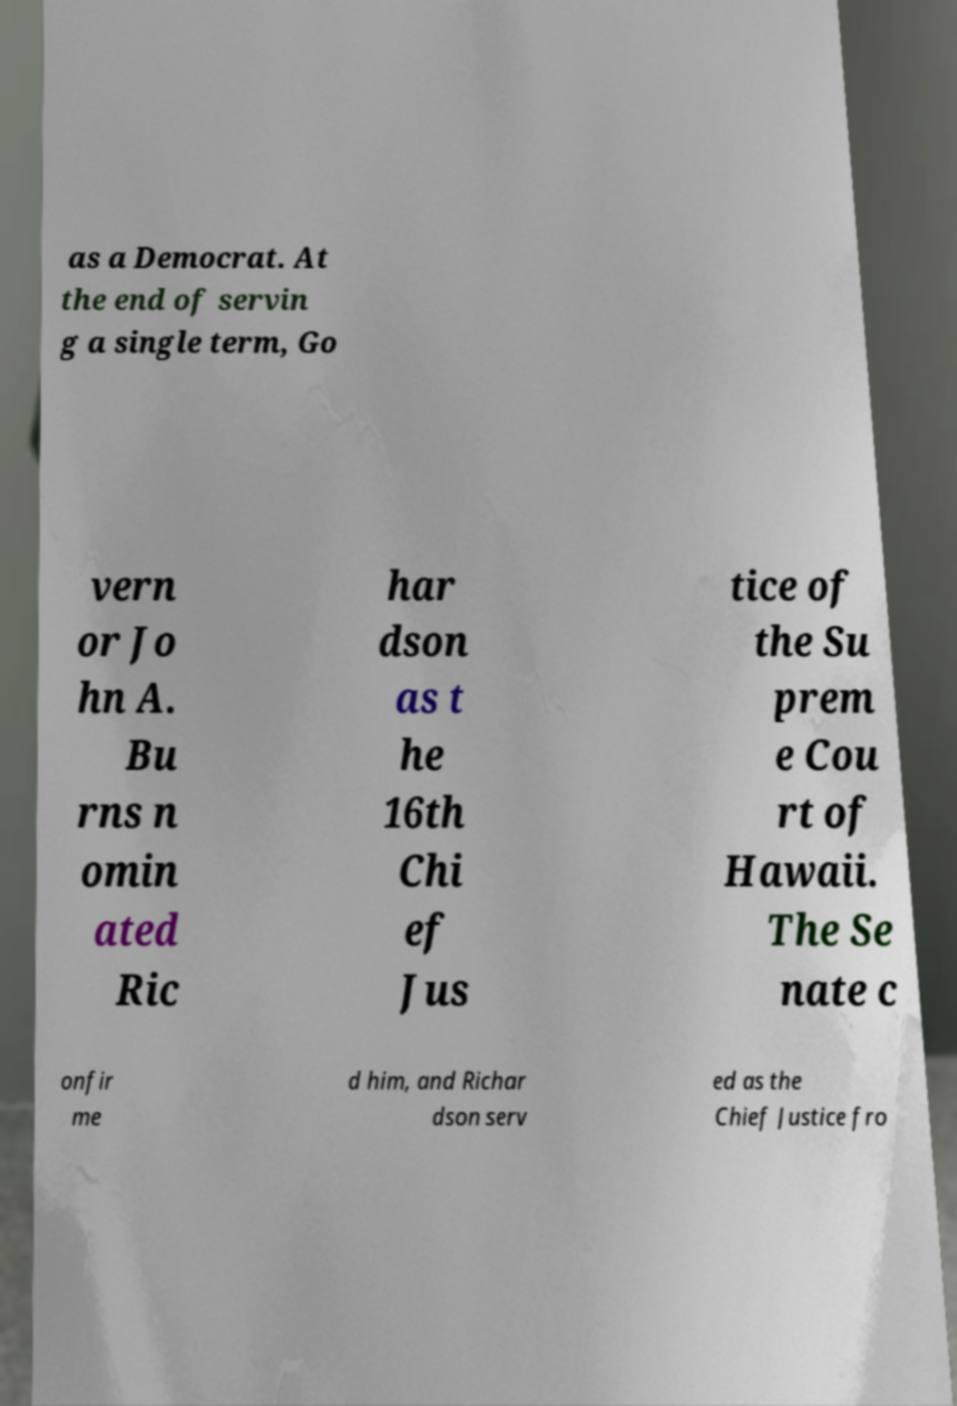There's text embedded in this image that I need extracted. Can you transcribe it verbatim? as a Democrat. At the end of servin g a single term, Go vern or Jo hn A. Bu rns n omin ated Ric har dson as t he 16th Chi ef Jus tice of the Su prem e Cou rt of Hawaii. The Se nate c onfir me d him, and Richar dson serv ed as the Chief Justice fro 